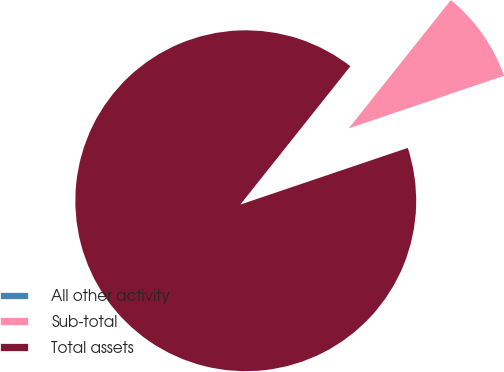<chart> <loc_0><loc_0><loc_500><loc_500><pie_chart><fcel>All other activity<fcel>Sub-total<fcel>Total assets<nl><fcel>0.01%<fcel>9.1%<fcel>90.89%<nl></chart> 